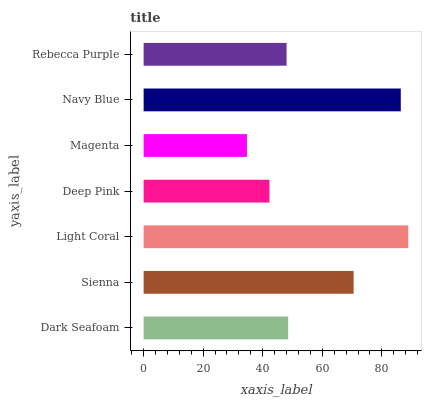Is Magenta the minimum?
Answer yes or no. Yes. Is Light Coral the maximum?
Answer yes or no. Yes. Is Sienna the minimum?
Answer yes or no. No. Is Sienna the maximum?
Answer yes or no. No. Is Sienna greater than Dark Seafoam?
Answer yes or no. Yes. Is Dark Seafoam less than Sienna?
Answer yes or no. Yes. Is Dark Seafoam greater than Sienna?
Answer yes or no. No. Is Sienna less than Dark Seafoam?
Answer yes or no. No. Is Dark Seafoam the high median?
Answer yes or no. Yes. Is Dark Seafoam the low median?
Answer yes or no. Yes. Is Rebecca Purple the high median?
Answer yes or no. No. Is Magenta the low median?
Answer yes or no. No. 